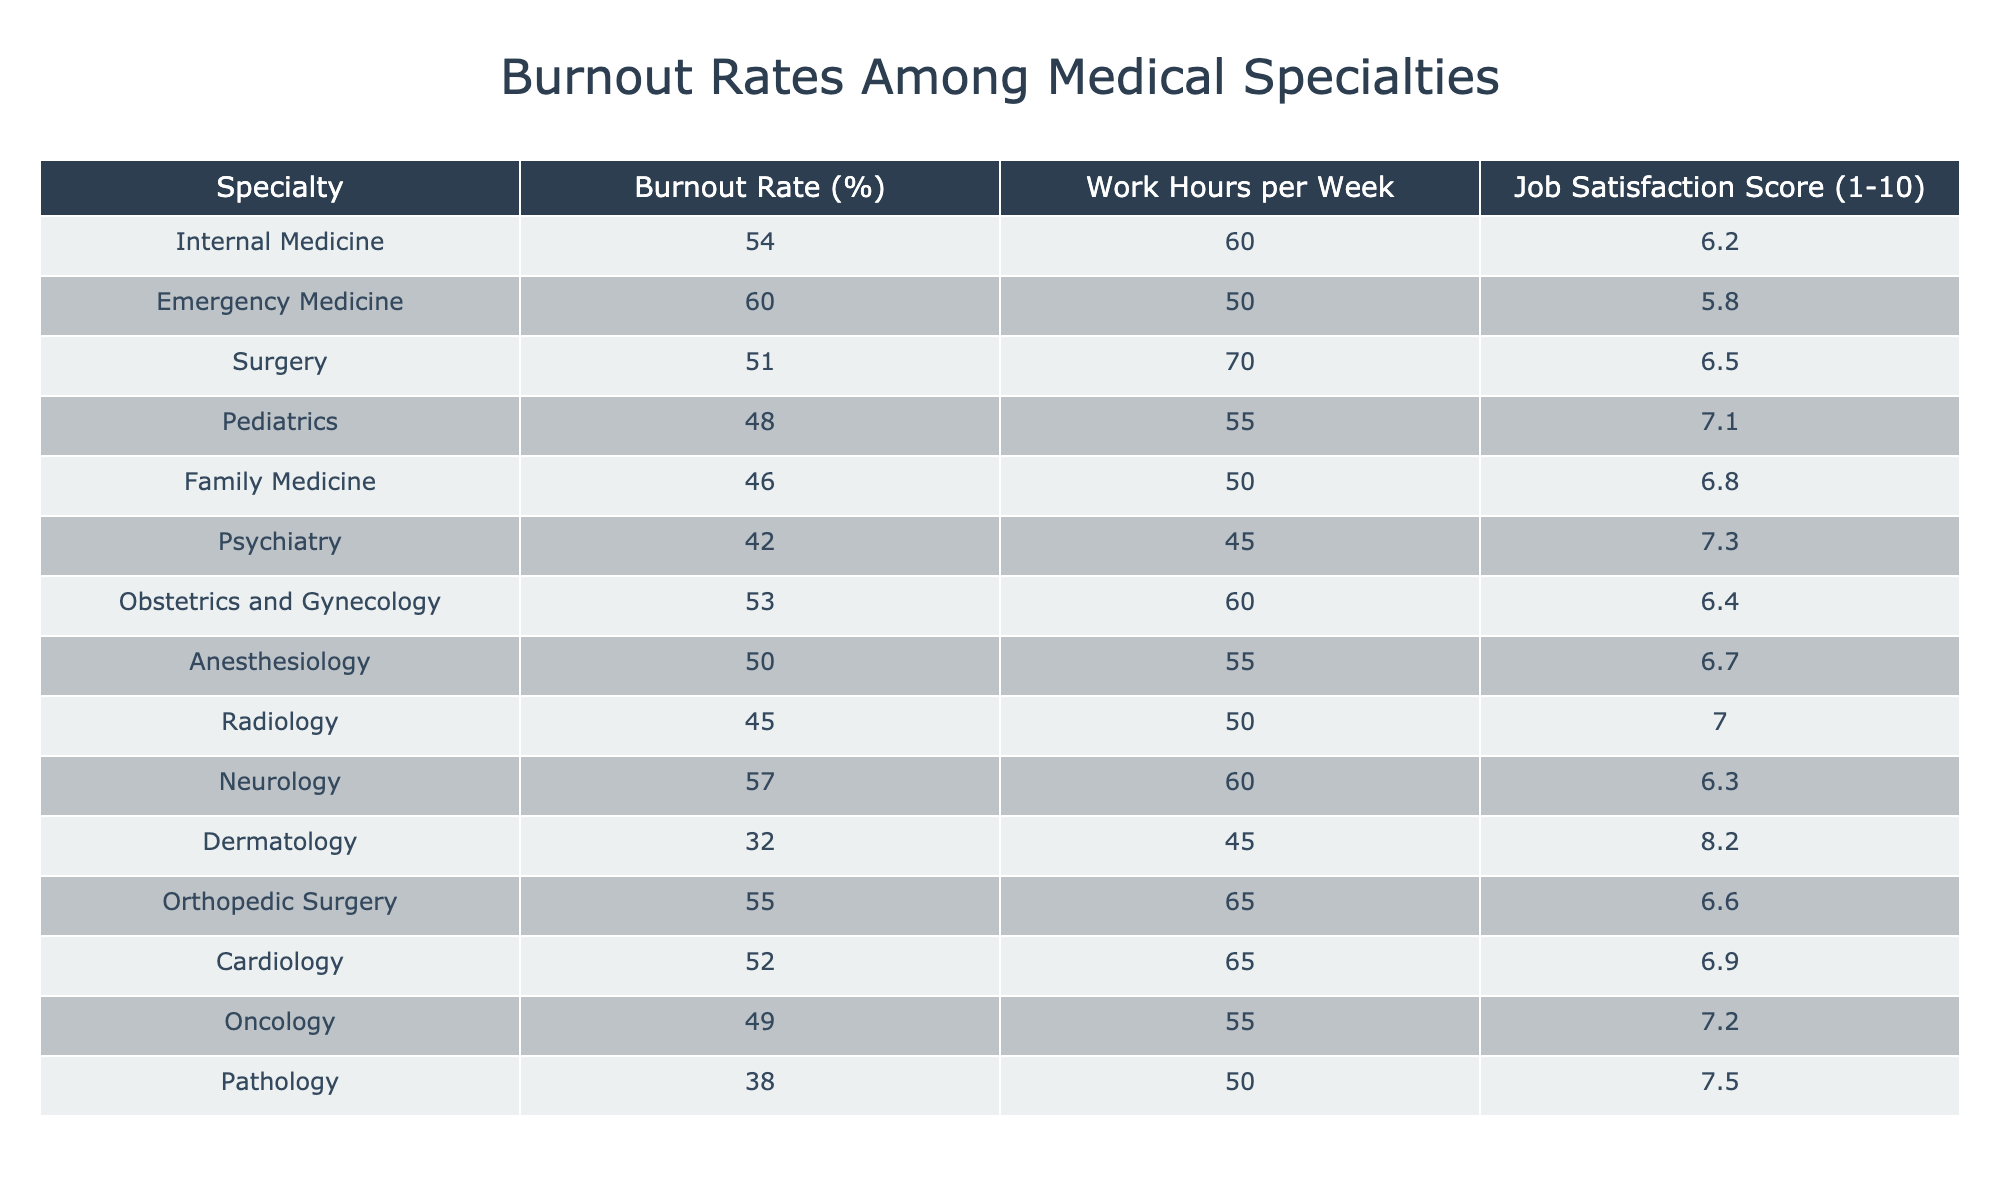What specialty has the highest burnout rate? By examining the first column, we see that Emergency Medicine has the highest burnout rate, listed as 60%.
Answer: Emergency Medicine What is the average job satisfaction score for the specialties with a burnout rate above 50%? The relevant specialties are Internal Medicine (6.2), Emergency Medicine (5.8), Surgery (6.5), Neurology (6.3), and Orthopedic Surgery (6.6). We sum these scores: 6.2 + 5.8 + 6.5 + 6.3 + 6.6 = 31.4. There are 5 specialties, so the average is 31.4 / 5 = 6.28.
Answer: 6.28 Is Pediatrics the specialty with the lowest burnout rate? The table shows that Dermatology has the lowest burnout rate at 32%, while Pediatrics has a burnout rate of 48%. Therefore, Pediatrics is not the lowest.
Answer: No What is the total number of work hours per week for the specialties with a job satisfaction score of 7 or above? The relevant specialties are Pediatrics (55), Psychiatry (45), Dermatology (45), Pathology (50), and Oncology (55). Summing these hours gives us: 55 + 45 + 45 + 50 + 55 = 250 hours.
Answer: 250 Which specialty has the highest job satisfaction score? Looking at the job satisfaction scores, Dermatology has the highest score of 8.2.
Answer: Dermatology What is the difference between the burnout rate of Internal Medicine and that of Family Medicine? Internal Medicine has a burnout rate of 54% while Family Medicine has a burnout rate of 46%. The difference is calculated as 54 - 46 = 8%.
Answer: 8% How many specialties have a burnout rate lower than 40%? Scanning the table, we see that only Dermatology, with a burnout rate of 32%, is below 40%. Thus, there is only one specialty with a burnout rate lower than 40%.
Answer: 1 What is the median work hours per week across all specialties? To find the median, we need to list all the work hours: 60, 50, 70, 55, 50, 45, 60, 55, 50, 60, 65, 65, 55, 50. Ordering them gives: 45, 50, 50, 50, 55, 55, 55, 60, 60, 60, 65, 65, 70. The median is the average of the 7th and 8th values (55 and 60), which is (55 + 60) / 2 = 57.5.
Answer: 57.5 What percentage of specialties have a job satisfaction score below 6.5? The specialties with a score below 6.5 are Emergency Medicine (5.8) and Family Medicine (6.3), which are 2 out of 14 total specialties. The percentage is (2 / 14) * 100 = 14.29%.
Answer: 14.29% 